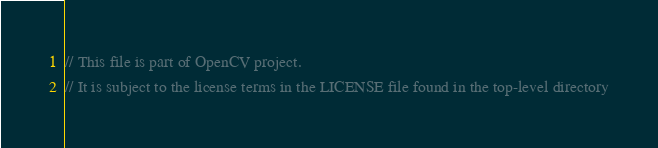Convert code to text. <code><loc_0><loc_0><loc_500><loc_500><_C++_>// This file is part of OpenCV project.
// It is subject to the license terms in the LICENSE file found in the top-level directory</code> 